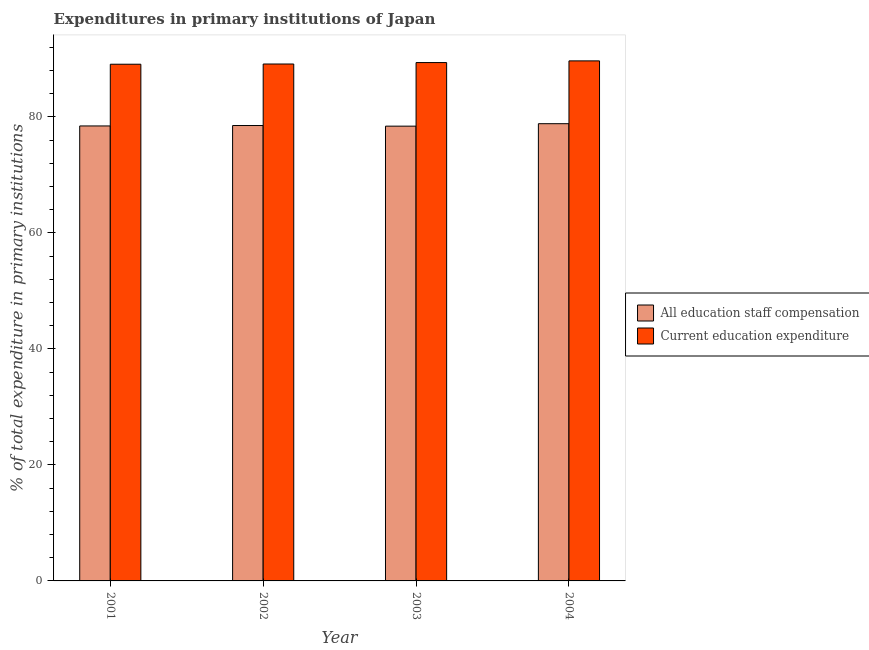How many groups of bars are there?
Provide a short and direct response. 4. Are the number of bars on each tick of the X-axis equal?
Provide a short and direct response. Yes. How many bars are there on the 3rd tick from the left?
Provide a short and direct response. 2. What is the expenditure in staff compensation in 2002?
Your answer should be very brief. 78.51. Across all years, what is the maximum expenditure in staff compensation?
Offer a terse response. 78.83. Across all years, what is the minimum expenditure in education?
Your answer should be very brief. 89.08. In which year was the expenditure in education maximum?
Make the answer very short. 2004. In which year was the expenditure in education minimum?
Give a very brief answer. 2001. What is the total expenditure in education in the graph?
Make the answer very short. 357.23. What is the difference between the expenditure in education in 2001 and that in 2003?
Your response must be concise. -0.28. What is the difference between the expenditure in staff compensation in 2001 and the expenditure in education in 2002?
Provide a succinct answer. -0.07. What is the average expenditure in education per year?
Your answer should be very brief. 89.31. In the year 2001, what is the difference between the expenditure in education and expenditure in staff compensation?
Your answer should be compact. 0. What is the ratio of the expenditure in staff compensation in 2002 to that in 2003?
Your answer should be very brief. 1. Is the difference between the expenditure in education in 2001 and 2004 greater than the difference between the expenditure in staff compensation in 2001 and 2004?
Ensure brevity in your answer.  No. What is the difference between the highest and the second highest expenditure in staff compensation?
Offer a terse response. 0.32. What is the difference between the highest and the lowest expenditure in staff compensation?
Ensure brevity in your answer.  0.42. Is the sum of the expenditure in staff compensation in 2002 and 2003 greater than the maximum expenditure in education across all years?
Keep it short and to the point. Yes. What does the 2nd bar from the left in 2002 represents?
Provide a succinct answer. Current education expenditure. What does the 2nd bar from the right in 2003 represents?
Make the answer very short. All education staff compensation. Are all the bars in the graph horizontal?
Make the answer very short. No. How many years are there in the graph?
Provide a succinct answer. 4. What is the difference between two consecutive major ticks on the Y-axis?
Provide a short and direct response. 20. Are the values on the major ticks of Y-axis written in scientific E-notation?
Give a very brief answer. No. Does the graph contain any zero values?
Your answer should be compact. No. Where does the legend appear in the graph?
Make the answer very short. Center right. How many legend labels are there?
Offer a terse response. 2. How are the legend labels stacked?
Your answer should be compact. Vertical. What is the title of the graph?
Offer a very short reply. Expenditures in primary institutions of Japan. Does "Canada" appear as one of the legend labels in the graph?
Your answer should be very brief. No. What is the label or title of the X-axis?
Give a very brief answer. Year. What is the label or title of the Y-axis?
Give a very brief answer. % of total expenditure in primary institutions. What is the % of total expenditure in primary institutions in All education staff compensation in 2001?
Your answer should be compact. 78.44. What is the % of total expenditure in primary institutions in Current education expenditure in 2001?
Offer a very short reply. 89.08. What is the % of total expenditure in primary institutions in All education staff compensation in 2002?
Make the answer very short. 78.51. What is the % of total expenditure in primary institutions of Current education expenditure in 2002?
Your response must be concise. 89.12. What is the % of total expenditure in primary institutions of All education staff compensation in 2003?
Your answer should be very brief. 78.41. What is the % of total expenditure in primary institutions of Current education expenditure in 2003?
Give a very brief answer. 89.37. What is the % of total expenditure in primary institutions in All education staff compensation in 2004?
Offer a terse response. 78.83. What is the % of total expenditure in primary institutions in Current education expenditure in 2004?
Your response must be concise. 89.66. Across all years, what is the maximum % of total expenditure in primary institutions in All education staff compensation?
Offer a very short reply. 78.83. Across all years, what is the maximum % of total expenditure in primary institutions in Current education expenditure?
Give a very brief answer. 89.66. Across all years, what is the minimum % of total expenditure in primary institutions in All education staff compensation?
Your answer should be compact. 78.41. Across all years, what is the minimum % of total expenditure in primary institutions in Current education expenditure?
Give a very brief answer. 89.08. What is the total % of total expenditure in primary institutions in All education staff compensation in the graph?
Offer a terse response. 314.19. What is the total % of total expenditure in primary institutions in Current education expenditure in the graph?
Offer a terse response. 357.23. What is the difference between the % of total expenditure in primary institutions in All education staff compensation in 2001 and that in 2002?
Offer a terse response. -0.07. What is the difference between the % of total expenditure in primary institutions in Current education expenditure in 2001 and that in 2002?
Provide a short and direct response. -0.04. What is the difference between the % of total expenditure in primary institutions in All education staff compensation in 2001 and that in 2003?
Your answer should be compact. 0.03. What is the difference between the % of total expenditure in primary institutions of Current education expenditure in 2001 and that in 2003?
Give a very brief answer. -0.28. What is the difference between the % of total expenditure in primary institutions of All education staff compensation in 2001 and that in 2004?
Provide a succinct answer. -0.39. What is the difference between the % of total expenditure in primary institutions of Current education expenditure in 2001 and that in 2004?
Your answer should be very brief. -0.58. What is the difference between the % of total expenditure in primary institutions in All education staff compensation in 2002 and that in 2003?
Provide a short and direct response. 0.11. What is the difference between the % of total expenditure in primary institutions of Current education expenditure in 2002 and that in 2003?
Provide a short and direct response. -0.25. What is the difference between the % of total expenditure in primary institutions in All education staff compensation in 2002 and that in 2004?
Provide a succinct answer. -0.32. What is the difference between the % of total expenditure in primary institutions in Current education expenditure in 2002 and that in 2004?
Offer a very short reply. -0.54. What is the difference between the % of total expenditure in primary institutions of All education staff compensation in 2003 and that in 2004?
Provide a short and direct response. -0.42. What is the difference between the % of total expenditure in primary institutions in Current education expenditure in 2003 and that in 2004?
Make the answer very short. -0.29. What is the difference between the % of total expenditure in primary institutions of All education staff compensation in 2001 and the % of total expenditure in primary institutions of Current education expenditure in 2002?
Provide a short and direct response. -10.68. What is the difference between the % of total expenditure in primary institutions of All education staff compensation in 2001 and the % of total expenditure in primary institutions of Current education expenditure in 2003?
Provide a succinct answer. -10.93. What is the difference between the % of total expenditure in primary institutions in All education staff compensation in 2001 and the % of total expenditure in primary institutions in Current education expenditure in 2004?
Your answer should be compact. -11.22. What is the difference between the % of total expenditure in primary institutions in All education staff compensation in 2002 and the % of total expenditure in primary institutions in Current education expenditure in 2003?
Give a very brief answer. -10.85. What is the difference between the % of total expenditure in primary institutions of All education staff compensation in 2002 and the % of total expenditure in primary institutions of Current education expenditure in 2004?
Ensure brevity in your answer.  -11.15. What is the difference between the % of total expenditure in primary institutions of All education staff compensation in 2003 and the % of total expenditure in primary institutions of Current education expenditure in 2004?
Keep it short and to the point. -11.25. What is the average % of total expenditure in primary institutions of All education staff compensation per year?
Ensure brevity in your answer.  78.55. What is the average % of total expenditure in primary institutions of Current education expenditure per year?
Your answer should be very brief. 89.31. In the year 2001, what is the difference between the % of total expenditure in primary institutions of All education staff compensation and % of total expenditure in primary institutions of Current education expenditure?
Keep it short and to the point. -10.64. In the year 2002, what is the difference between the % of total expenditure in primary institutions in All education staff compensation and % of total expenditure in primary institutions in Current education expenditure?
Your answer should be very brief. -10.61. In the year 2003, what is the difference between the % of total expenditure in primary institutions in All education staff compensation and % of total expenditure in primary institutions in Current education expenditure?
Ensure brevity in your answer.  -10.96. In the year 2004, what is the difference between the % of total expenditure in primary institutions in All education staff compensation and % of total expenditure in primary institutions in Current education expenditure?
Your answer should be very brief. -10.83. What is the ratio of the % of total expenditure in primary institutions of All education staff compensation in 2001 to that in 2002?
Make the answer very short. 1. What is the ratio of the % of total expenditure in primary institutions in Current education expenditure in 2001 to that in 2003?
Provide a short and direct response. 1. What is the ratio of the % of total expenditure in primary institutions in All education staff compensation in 2002 to that in 2003?
Offer a terse response. 1. What is the ratio of the % of total expenditure in primary institutions of Current education expenditure in 2002 to that in 2004?
Keep it short and to the point. 0.99. What is the ratio of the % of total expenditure in primary institutions in Current education expenditure in 2003 to that in 2004?
Ensure brevity in your answer.  1. What is the difference between the highest and the second highest % of total expenditure in primary institutions of All education staff compensation?
Offer a terse response. 0.32. What is the difference between the highest and the second highest % of total expenditure in primary institutions of Current education expenditure?
Your response must be concise. 0.29. What is the difference between the highest and the lowest % of total expenditure in primary institutions in All education staff compensation?
Your response must be concise. 0.42. What is the difference between the highest and the lowest % of total expenditure in primary institutions of Current education expenditure?
Keep it short and to the point. 0.58. 